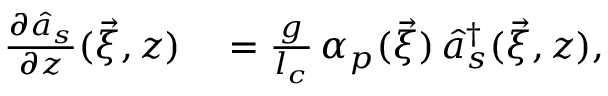Convert formula to latex. <formula><loc_0><loc_0><loc_500><loc_500>\begin{array} { r l } { \frac { \partial \hat { a } _ { s } } { \partial z } ( \vec { \xi } , z ) } & = \frac { g } { l _ { c } } \, { \alpha } _ { p } ( \vec { \xi } ) \, \hat { a } _ { s } ^ { \dagger } ( \vec { \xi } , z ) , } \end{array}</formula> 